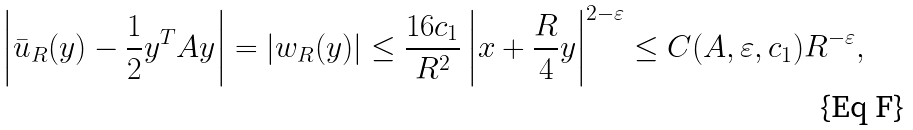Convert formula to latex. <formula><loc_0><loc_0><loc_500><loc_500>\left | \bar { u } _ { R } ( y ) - \frac { 1 } { 2 } y ^ { T } A y \right | = | w _ { R } ( y ) | \leq \frac { 1 6 c _ { 1 } } { R ^ { 2 } } \left | x + \frac { R } { 4 } y \right | ^ { 2 - \varepsilon } \leq C ( A , \varepsilon , c _ { 1 } ) R ^ { - \varepsilon } ,</formula> 